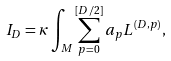Convert formula to latex. <formula><loc_0><loc_0><loc_500><loc_500>I _ { D } = \kappa \int _ { M } \sum _ { p = 0 } ^ { [ D / 2 ] } a _ { p } L ^ { ( D , p ) } ,</formula> 